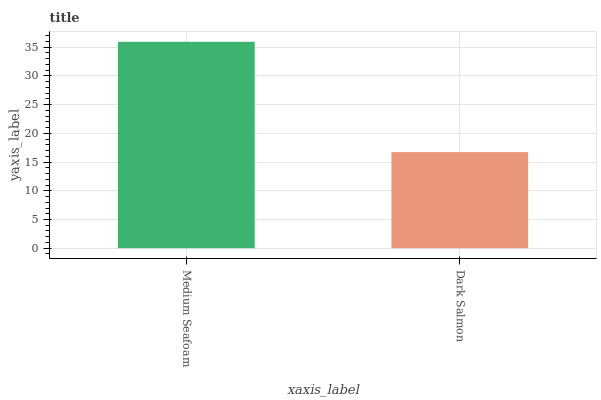Is Dark Salmon the minimum?
Answer yes or no. Yes. Is Medium Seafoam the maximum?
Answer yes or no. Yes. Is Dark Salmon the maximum?
Answer yes or no. No. Is Medium Seafoam greater than Dark Salmon?
Answer yes or no. Yes. Is Dark Salmon less than Medium Seafoam?
Answer yes or no. Yes. Is Dark Salmon greater than Medium Seafoam?
Answer yes or no. No. Is Medium Seafoam less than Dark Salmon?
Answer yes or no. No. Is Medium Seafoam the high median?
Answer yes or no. Yes. Is Dark Salmon the low median?
Answer yes or no. Yes. Is Dark Salmon the high median?
Answer yes or no. No. Is Medium Seafoam the low median?
Answer yes or no. No. 